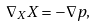<formula> <loc_0><loc_0><loc_500><loc_500>\nabla _ { X } X = - \nabla p ,</formula> 